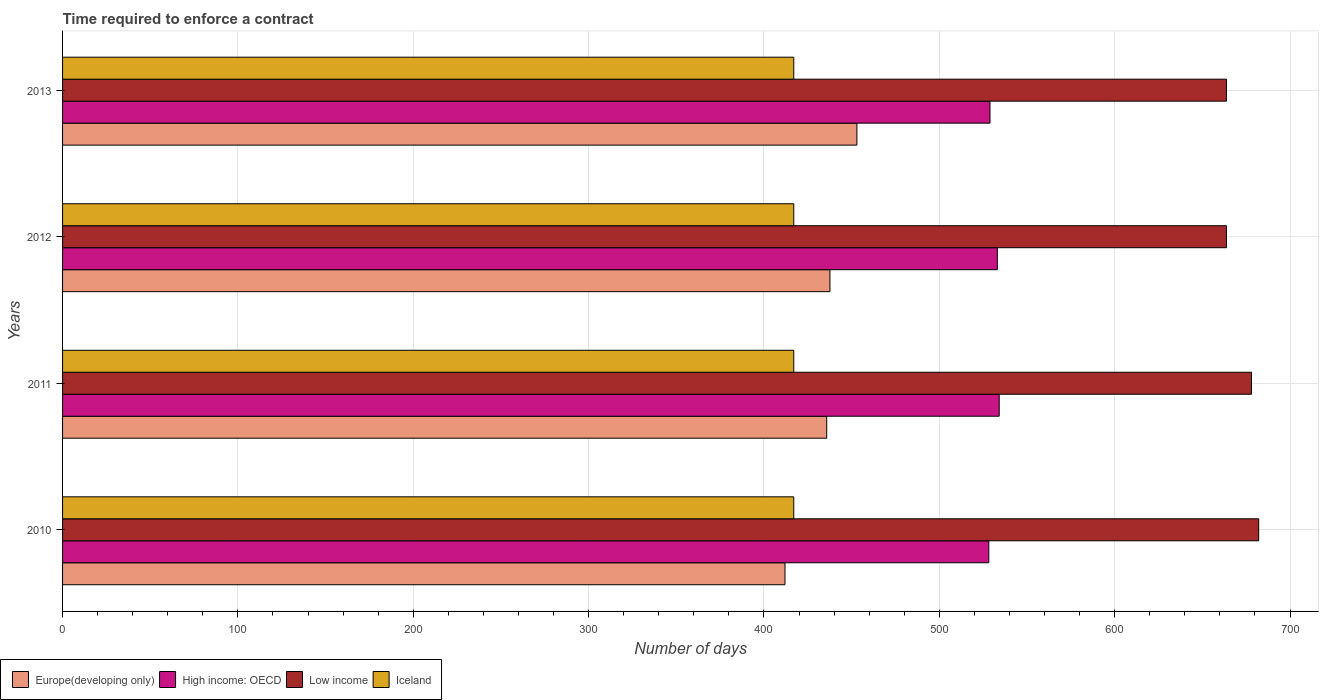How many different coloured bars are there?
Your answer should be compact. 4. How many bars are there on the 1st tick from the top?
Offer a terse response. 4. How many bars are there on the 2nd tick from the bottom?
Offer a very short reply. 4. What is the label of the 3rd group of bars from the top?
Make the answer very short. 2011. In how many cases, is the number of bars for a given year not equal to the number of legend labels?
Make the answer very short. 0. What is the number of days required to enforce a contract in Iceland in 2010?
Offer a terse response. 417. Across all years, what is the maximum number of days required to enforce a contract in Low income?
Your response must be concise. 682.14. Across all years, what is the minimum number of days required to enforce a contract in High income: OECD?
Your answer should be very brief. 528.23. In which year was the number of days required to enforce a contract in Low income maximum?
Your answer should be very brief. 2010. What is the total number of days required to enforce a contract in Low income in the graph?
Keep it short and to the point. 2687.7. What is the difference between the number of days required to enforce a contract in Europe(developing only) in 2011 and that in 2012?
Provide a succinct answer. -1.84. What is the difference between the number of days required to enforce a contract in Iceland in 2011 and the number of days required to enforce a contract in Europe(developing only) in 2013?
Give a very brief answer. -36. What is the average number of days required to enforce a contract in Europe(developing only) per year?
Provide a succinct answer. 434.61. In the year 2010, what is the difference between the number of days required to enforce a contract in Iceland and number of days required to enforce a contract in Europe(developing only)?
Make the answer very short. 5. In how many years, is the number of days required to enforce a contract in Low income greater than 520 days?
Offer a terse response. 4. What is the ratio of the number of days required to enforce a contract in Europe(developing only) in 2010 to that in 2012?
Ensure brevity in your answer.  0.94. Is the number of days required to enforce a contract in Iceland in 2010 less than that in 2012?
Offer a terse response. No. What is the difference between the highest and the second highest number of days required to enforce a contract in Iceland?
Provide a short and direct response. 0. What is the difference between the highest and the lowest number of days required to enforce a contract in High income: OECD?
Your answer should be very brief. 5.93. In how many years, is the number of days required to enforce a contract in Low income greater than the average number of days required to enforce a contract in Low income taken over all years?
Make the answer very short. 2. Is it the case that in every year, the sum of the number of days required to enforce a contract in Low income and number of days required to enforce a contract in Europe(developing only) is greater than the sum of number of days required to enforce a contract in Iceland and number of days required to enforce a contract in High income: OECD?
Offer a terse response. Yes. What does the 1st bar from the bottom in 2013 represents?
Give a very brief answer. Europe(developing only). Are all the bars in the graph horizontal?
Offer a very short reply. Yes. How many years are there in the graph?
Give a very brief answer. 4. What is the difference between two consecutive major ticks on the X-axis?
Offer a terse response. 100. How many legend labels are there?
Your response must be concise. 4. What is the title of the graph?
Offer a terse response. Time required to enforce a contract. Does "Bulgaria" appear as one of the legend labels in the graph?
Give a very brief answer. No. What is the label or title of the X-axis?
Provide a succinct answer. Number of days. What is the label or title of the Y-axis?
Make the answer very short. Years. What is the Number of days in Europe(developing only) in 2010?
Your answer should be very brief. 412. What is the Number of days of High income: OECD in 2010?
Your answer should be compact. 528.23. What is the Number of days of Low income in 2010?
Make the answer very short. 682.14. What is the Number of days in Iceland in 2010?
Provide a succinct answer. 417. What is the Number of days of Europe(developing only) in 2011?
Your response must be concise. 435.79. What is the Number of days in High income: OECD in 2011?
Ensure brevity in your answer.  534.17. What is the Number of days of Low income in 2011?
Make the answer very short. 678.04. What is the Number of days in Iceland in 2011?
Make the answer very short. 417. What is the Number of days in Europe(developing only) in 2012?
Your answer should be very brief. 437.63. What is the Number of days in High income: OECD in 2012?
Offer a terse response. 533.1. What is the Number of days in Low income in 2012?
Your answer should be very brief. 663.76. What is the Number of days in Iceland in 2012?
Your response must be concise. 417. What is the Number of days of Europe(developing only) in 2013?
Your response must be concise. 453. What is the Number of days in High income: OECD in 2013?
Your answer should be compact. 528.91. What is the Number of days in Low income in 2013?
Keep it short and to the point. 663.76. What is the Number of days of Iceland in 2013?
Offer a very short reply. 417. Across all years, what is the maximum Number of days of Europe(developing only)?
Give a very brief answer. 453. Across all years, what is the maximum Number of days in High income: OECD?
Give a very brief answer. 534.17. Across all years, what is the maximum Number of days in Low income?
Your response must be concise. 682.14. Across all years, what is the maximum Number of days of Iceland?
Make the answer very short. 417. Across all years, what is the minimum Number of days in Europe(developing only)?
Ensure brevity in your answer.  412. Across all years, what is the minimum Number of days of High income: OECD?
Keep it short and to the point. 528.23. Across all years, what is the minimum Number of days in Low income?
Offer a terse response. 663.76. Across all years, what is the minimum Number of days in Iceland?
Your answer should be compact. 417. What is the total Number of days of Europe(developing only) in the graph?
Provide a short and direct response. 1738.42. What is the total Number of days in High income: OECD in the graph?
Provide a short and direct response. 2124.41. What is the total Number of days in Low income in the graph?
Offer a terse response. 2687.7. What is the total Number of days of Iceland in the graph?
Provide a short and direct response. 1668. What is the difference between the Number of days of Europe(developing only) in 2010 and that in 2011?
Your answer should be very brief. -23.79. What is the difference between the Number of days of High income: OECD in 2010 and that in 2011?
Your response must be concise. -5.93. What is the difference between the Number of days of Low income in 2010 and that in 2011?
Offer a very short reply. 4.11. What is the difference between the Number of days in Europe(developing only) in 2010 and that in 2012?
Give a very brief answer. -25.63. What is the difference between the Number of days of High income: OECD in 2010 and that in 2012?
Keep it short and to the point. -4.87. What is the difference between the Number of days in Low income in 2010 and that in 2012?
Your answer should be compact. 18.38. What is the difference between the Number of days in Europe(developing only) in 2010 and that in 2013?
Make the answer very short. -41. What is the difference between the Number of days of High income: OECD in 2010 and that in 2013?
Give a very brief answer. -0.67. What is the difference between the Number of days of Low income in 2010 and that in 2013?
Your response must be concise. 18.38. What is the difference between the Number of days of Europe(developing only) in 2011 and that in 2012?
Give a very brief answer. -1.84. What is the difference between the Number of days in High income: OECD in 2011 and that in 2012?
Make the answer very short. 1.07. What is the difference between the Number of days of Low income in 2011 and that in 2012?
Provide a succinct answer. 14.28. What is the difference between the Number of days of Iceland in 2011 and that in 2012?
Offer a very short reply. 0. What is the difference between the Number of days in Europe(developing only) in 2011 and that in 2013?
Offer a terse response. -17.21. What is the difference between the Number of days of High income: OECD in 2011 and that in 2013?
Make the answer very short. 5.26. What is the difference between the Number of days in Low income in 2011 and that in 2013?
Make the answer very short. 14.28. What is the difference between the Number of days in Iceland in 2011 and that in 2013?
Your answer should be very brief. 0. What is the difference between the Number of days in Europe(developing only) in 2012 and that in 2013?
Make the answer very short. -15.37. What is the difference between the Number of days in High income: OECD in 2012 and that in 2013?
Keep it short and to the point. 4.19. What is the difference between the Number of days in Europe(developing only) in 2010 and the Number of days in High income: OECD in 2011?
Keep it short and to the point. -122.17. What is the difference between the Number of days in Europe(developing only) in 2010 and the Number of days in Low income in 2011?
Your answer should be very brief. -266.04. What is the difference between the Number of days in Europe(developing only) in 2010 and the Number of days in Iceland in 2011?
Your answer should be compact. -5. What is the difference between the Number of days in High income: OECD in 2010 and the Number of days in Low income in 2011?
Keep it short and to the point. -149.8. What is the difference between the Number of days in High income: OECD in 2010 and the Number of days in Iceland in 2011?
Provide a succinct answer. 111.23. What is the difference between the Number of days in Low income in 2010 and the Number of days in Iceland in 2011?
Make the answer very short. 265.14. What is the difference between the Number of days of Europe(developing only) in 2010 and the Number of days of High income: OECD in 2012?
Offer a very short reply. -121.1. What is the difference between the Number of days of Europe(developing only) in 2010 and the Number of days of Low income in 2012?
Your response must be concise. -251.76. What is the difference between the Number of days of High income: OECD in 2010 and the Number of days of Low income in 2012?
Ensure brevity in your answer.  -135.53. What is the difference between the Number of days in High income: OECD in 2010 and the Number of days in Iceland in 2012?
Make the answer very short. 111.23. What is the difference between the Number of days in Low income in 2010 and the Number of days in Iceland in 2012?
Your answer should be compact. 265.14. What is the difference between the Number of days in Europe(developing only) in 2010 and the Number of days in High income: OECD in 2013?
Your answer should be very brief. -116.91. What is the difference between the Number of days in Europe(developing only) in 2010 and the Number of days in Low income in 2013?
Provide a succinct answer. -251.76. What is the difference between the Number of days of Europe(developing only) in 2010 and the Number of days of Iceland in 2013?
Offer a very short reply. -5. What is the difference between the Number of days in High income: OECD in 2010 and the Number of days in Low income in 2013?
Offer a terse response. -135.53. What is the difference between the Number of days of High income: OECD in 2010 and the Number of days of Iceland in 2013?
Provide a short and direct response. 111.23. What is the difference between the Number of days in Low income in 2010 and the Number of days in Iceland in 2013?
Make the answer very short. 265.14. What is the difference between the Number of days in Europe(developing only) in 2011 and the Number of days in High income: OECD in 2012?
Your answer should be compact. -97.31. What is the difference between the Number of days of Europe(developing only) in 2011 and the Number of days of Low income in 2012?
Provide a short and direct response. -227.97. What is the difference between the Number of days in Europe(developing only) in 2011 and the Number of days in Iceland in 2012?
Give a very brief answer. 18.79. What is the difference between the Number of days in High income: OECD in 2011 and the Number of days in Low income in 2012?
Your answer should be compact. -129.59. What is the difference between the Number of days of High income: OECD in 2011 and the Number of days of Iceland in 2012?
Provide a short and direct response. 117.17. What is the difference between the Number of days in Low income in 2011 and the Number of days in Iceland in 2012?
Your response must be concise. 261.04. What is the difference between the Number of days of Europe(developing only) in 2011 and the Number of days of High income: OECD in 2013?
Provide a short and direct response. -93.12. What is the difference between the Number of days of Europe(developing only) in 2011 and the Number of days of Low income in 2013?
Give a very brief answer. -227.97. What is the difference between the Number of days in Europe(developing only) in 2011 and the Number of days in Iceland in 2013?
Make the answer very short. 18.79. What is the difference between the Number of days in High income: OECD in 2011 and the Number of days in Low income in 2013?
Ensure brevity in your answer.  -129.59. What is the difference between the Number of days in High income: OECD in 2011 and the Number of days in Iceland in 2013?
Your answer should be very brief. 117.17. What is the difference between the Number of days in Low income in 2011 and the Number of days in Iceland in 2013?
Offer a very short reply. 261.04. What is the difference between the Number of days of Europe(developing only) in 2012 and the Number of days of High income: OECD in 2013?
Give a very brief answer. -91.27. What is the difference between the Number of days of Europe(developing only) in 2012 and the Number of days of Low income in 2013?
Keep it short and to the point. -226.13. What is the difference between the Number of days of Europe(developing only) in 2012 and the Number of days of Iceland in 2013?
Your response must be concise. 20.63. What is the difference between the Number of days of High income: OECD in 2012 and the Number of days of Low income in 2013?
Your response must be concise. -130.66. What is the difference between the Number of days of High income: OECD in 2012 and the Number of days of Iceland in 2013?
Your answer should be compact. 116.1. What is the difference between the Number of days in Low income in 2012 and the Number of days in Iceland in 2013?
Offer a very short reply. 246.76. What is the average Number of days of Europe(developing only) per year?
Provide a succinct answer. 434.61. What is the average Number of days of High income: OECD per year?
Ensure brevity in your answer.  531.1. What is the average Number of days of Low income per year?
Your response must be concise. 671.92. What is the average Number of days in Iceland per year?
Provide a short and direct response. 417. In the year 2010, what is the difference between the Number of days of Europe(developing only) and Number of days of High income: OECD?
Give a very brief answer. -116.23. In the year 2010, what is the difference between the Number of days in Europe(developing only) and Number of days in Low income?
Provide a succinct answer. -270.14. In the year 2010, what is the difference between the Number of days in Europe(developing only) and Number of days in Iceland?
Provide a short and direct response. -5. In the year 2010, what is the difference between the Number of days of High income: OECD and Number of days of Low income?
Offer a terse response. -153.91. In the year 2010, what is the difference between the Number of days of High income: OECD and Number of days of Iceland?
Provide a short and direct response. 111.23. In the year 2010, what is the difference between the Number of days of Low income and Number of days of Iceland?
Your answer should be compact. 265.14. In the year 2011, what is the difference between the Number of days of Europe(developing only) and Number of days of High income: OECD?
Your response must be concise. -98.38. In the year 2011, what is the difference between the Number of days of Europe(developing only) and Number of days of Low income?
Your response must be concise. -242.25. In the year 2011, what is the difference between the Number of days in Europe(developing only) and Number of days in Iceland?
Keep it short and to the point. 18.79. In the year 2011, what is the difference between the Number of days in High income: OECD and Number of days in Low income?
Ensure brevity in your answer.  -143.87. In the year 2011, what is the difference between the Number of days in High income: OECD and Number of days in Iceland?
Your response must be concise. 117.17. In the year 2011, what is the difference between the Number of days of Low income and Number of days of Iceland?
Your answer should be compact. 261.04. In the year 2012, what is the difference between the Number of days of Europe(developing only) and Number of days of High income: OECD?
Your answer should be compact. -95.47. In the year 2012, what is the difference between the Number of days in Europe(developing only) and Number of days in Low income?
Give a very brief answer. -226.13. In the year 2012, what is the difference between the Number of days in Europe(developing only) and Number of days in Iceland?
Provide a succinct answer. 20.63. In the year 2012, what is the difference between the Number of days of High income: OECD and Number of days of Low income?
Your response must be concise. -130.66. In the year 2012, what is the difference between the Number of days of High income: OECD and Number of days of Iceland?
Your answer should be compact. 116.1. In the year 2012, what is the difference between the Number of days in Low income and Number of days in Iceland?
Keep it short and to the point. 246.76. In the year 2013, what is the difference between the Number of days in Europe(developing only) and Number of days in High income: OECD?
Provide a short and direct response. -75.91. In the year 2013, what is the difference between the Number of days of Europe(developing only) and Number of days of Low income?
Your answer should be very brief. -210.76. In the year 2013, what is the difference between the Number of days in Europe(developing only) and Number of days in Iceland?
Ensure brevity in your answer.  36. In the year 2013, what is the difference between the Number of days in High income: OECD and Number of days in Low income?
Offer a very short reply. -134.85. In the year 2013, what is the difference between the Number of days of High income: OECD and Number of days of Iceland?
Your response must be concise. 111.91. In the year 2013, what is the difference between the Number of days in Low income and Number of days in Iceland?
Make the answer very short. 246.76. What is the ratio of the Number of days of Europe(developing only) in 2010 to that in 2011?
Ensure brevity in your answer.  0.95. What is the ratio of the Number of days in High income: OECD in 2010 to that in 2011?
Your response must be concise. 0.99. What is the ratio of the Number of days of Iceland in 2010 to that in 2011?
Offer a terse response. 1. What is the ratio of the Number of days of Europe(developing only) in 2010 to that in 2012?
Your answer should be compact. 0.94. What is the ratio of the Number of days of High income: OECD in 2010 to that in 2012?
Make the answer very short. 0.99. What is the ratio of the Number of days in Low income in 2010 to that in 2012?
Your answer should be compact. 1.03. What is the ratio of the Number of days of Europe(developing only) in 2010 to that in 2013?
Offer a very short reply. 0.91. What is the ratio of the Number of days of Low income in 2010 to that in 2013?
Keep it short and to the point. 1.03. What is the ratio of the Number of days in High income: OECD in 2011 to that in 2012?
Keep it short and to the point. 1. What is the ratio of the Number of days of Low income in 2011 to that in 2012?
Give a very brief answer. 1.02. What is the ratio of the Number of days in High income: OECD in 2011 to that in 2013?
Offer a terse response. 1.01. What is the ratio of the Number of days in Low income in 2011 to that in 2013?
Provide a succinct answer. 1.02. What is the ratio of the Number of days in Europe(developing only) in 2012 to that in 2013?
Keep it short and to the point. 0.97. What is the ratio of the Number of days in High income: OECD in 2012 to that in 2013?
Keep it short and to the point. 1.01. What is the ratio of the Number of days in Low income in 2012 to that in 2013?
Make the answer very short. 1. What is the ratio of the Number of days of Iceland in 2012 to that in 2013?
Provide a short and direct response. 1. What is the difference between the highest and the second highest Number of days of Europe(developing only)?
Offer a terse response. 15.37. What is the difference between the highest and the second highest Number of days in High income: OECD?
Your response must be concise. 1.07. What is the difference between the highest and the second highest Number of days in Low income?
Your answer should be very brief. 4.11. What is the difference between the highest and the lowest Number of days in High income: OECD?
Provide a short and direct response. 5.93. What is the difference between the highest and the lowest Number of days in Low income?
Your response must be concise. 18.38. 